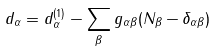<formula> <loc_0><loc_0><loc_500><loc_500>d _ { \alpha } = d _ { \alpha } ^ { ( 1 ) } - \sum _ { \beta } g _ { \alpha \beta } ( N _ { \beta } - \delta _ { \alpha \beta } )</formula> 